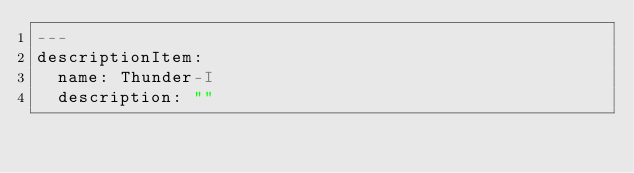Convert code to text. <code><loc_0><loc_0><loc_500><loc_500><_YAML_>---
descriptionItem:
  name: Thunder-I
  description: ""
</code> 